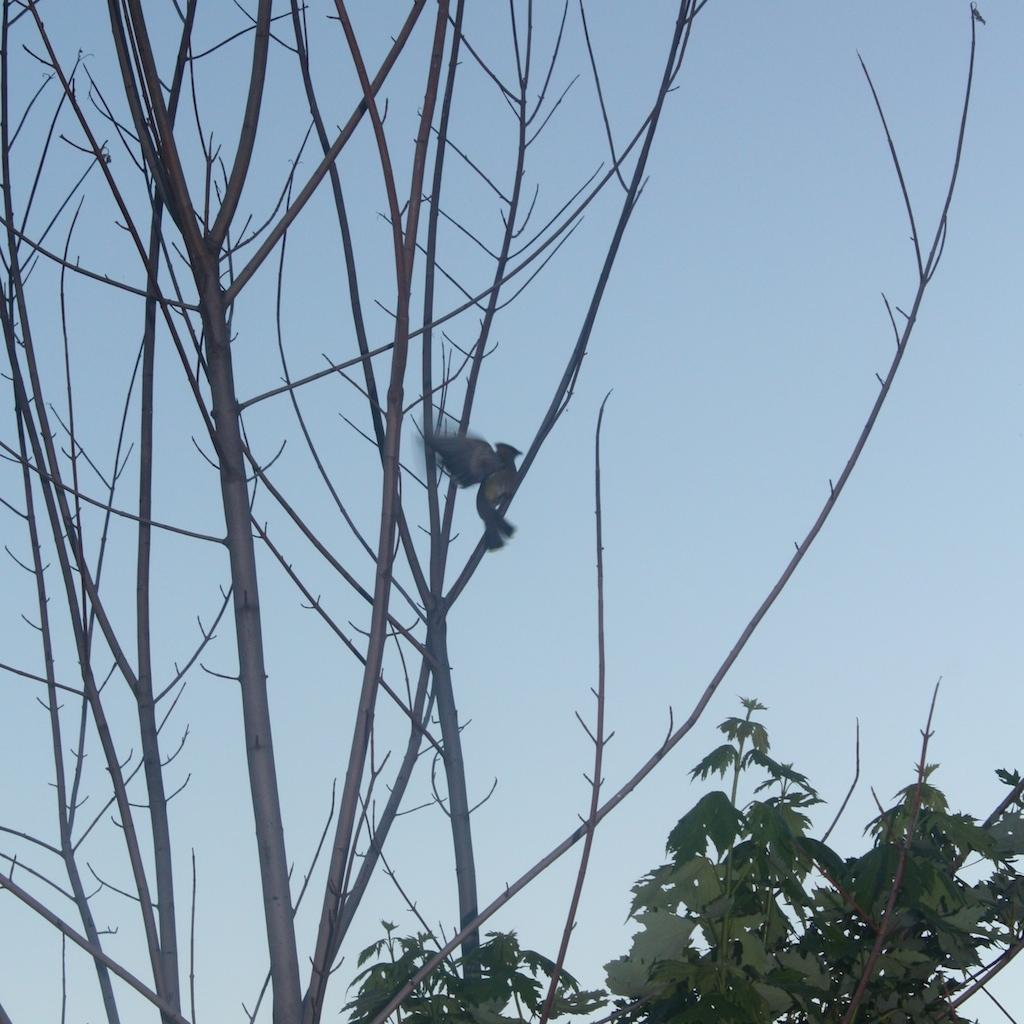Where was the picture taken? The picture was clicked outside the city. What can be seen on the stem of a tree in the image? There is a bird on the stem of a tree in the image. What type of vegetation is visible in the image? There are plants visible in the image. What is visible in the background of the image? The sky is visible in the background of the image. What caption is written on the bird in the image? There is no caption written on the bird in the image. Does the bird in the image express regret? The image does not convey any emotions or expressions from the bird, so it cannot be determined if it expresses regret. 